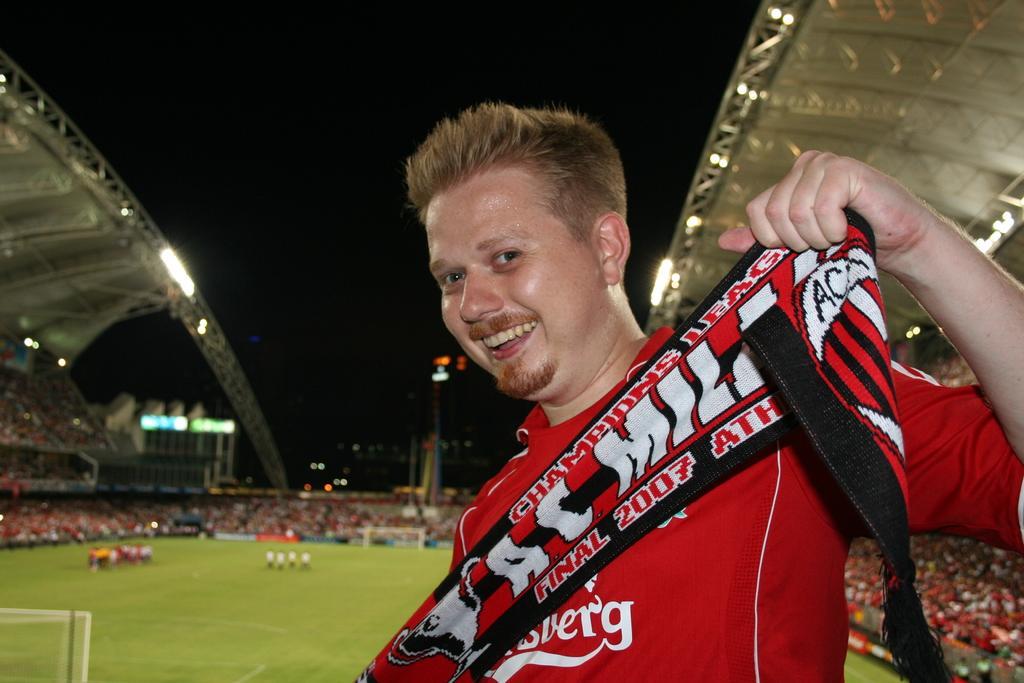Please provide a concise description of this image. In this image in the foreground there is a person holding a cloth, behind the man there is a stadium, on which there is crowd, on the ground in the middle there are few people, vehicle, pole, at the top there may be the sky, there are some lights attached to the roof. 